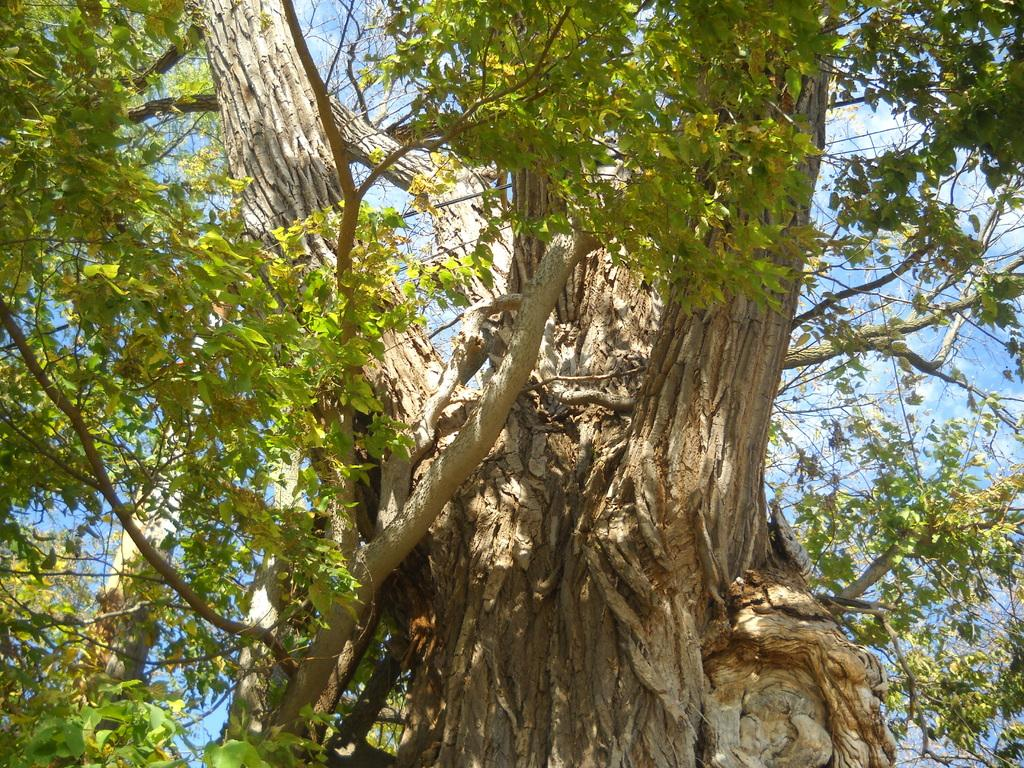What type of plant can be seen in the image? There is a tree in the image. What part of the natural environment is visible in the image? The sky is visible in the background of the image. What type of string is being used in the process depicted in the image? There is no process or string present in the image; it features a tree and the sky. 